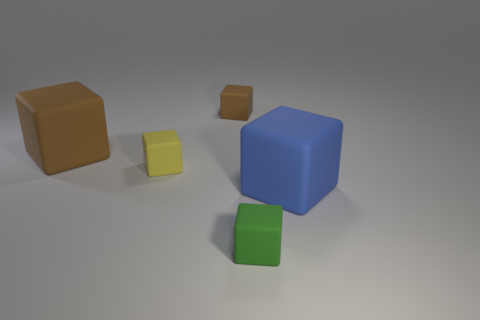Subtract all big blue rubber cubes. How many cubes are left? 4 Add 1 tiny red rubber balls. How many objects exist? 6 Subtract all blue blocks. How many blocks are left? 4 Subtract 1 cubes. How many cubes are left? 4 Add 3 small red blocks. How many small red blocks exist? 3 Subtract 0 purple spheres. How many objects are left? 5 Subtract all purple blocks. Subtract all cyan cylinders. How many blocks are left? 5 Subtract all red balls. How many red cubes are left? 0 Subtract all tiny cyan balls. Subtract all green objects. How many objects are left? 4 Add 1 large blue rubber things. How many large blue rubber things are left? 2 